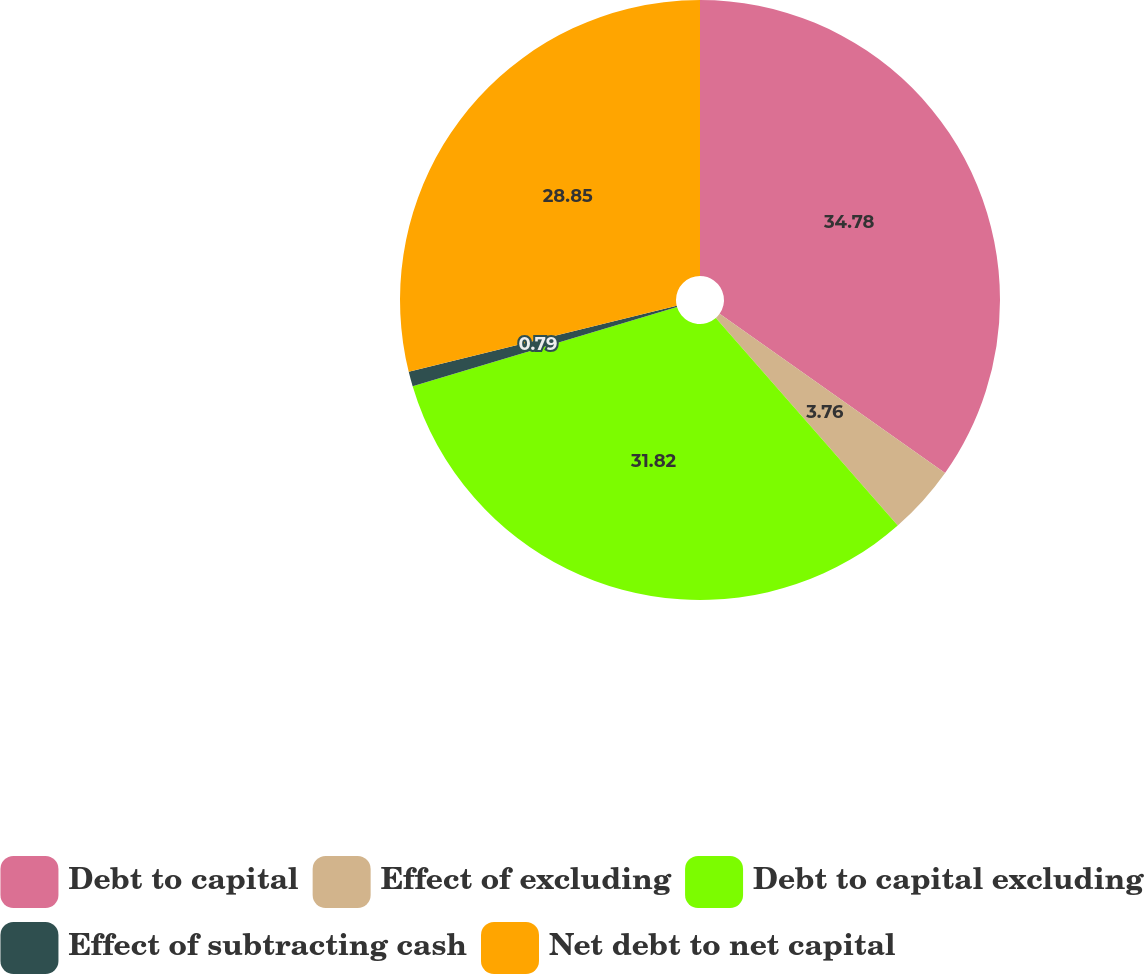<chart> <loc_0><loc_0><loc_500><loc_500><pie_chart><fcel>Debt to capital<fcel>Effect of excluding<fcel>Debt to capital excluding<fcel>Effect of subtracting cash<fcel>Net debt to net capital<nl><fcel>34.79%<fcel>3.76%<fcel>31.82%<fcel>0.79%<fcel>28.85%<nl></chart> 